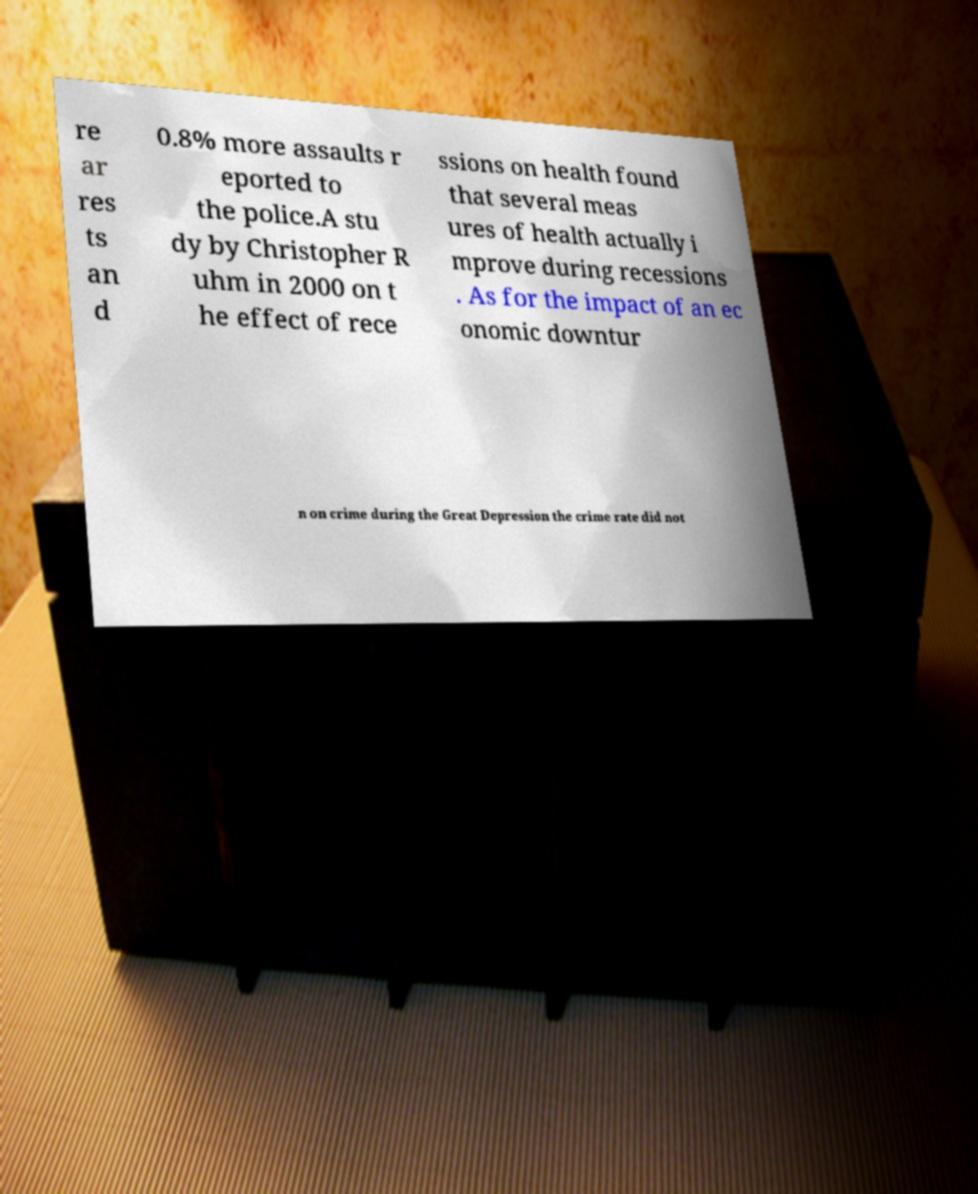Can you read and provide the text displayed in the image?This photo seems to have some interesting text. Can you extract and type it out for me? re ar res ts an d 0.8% more assaults r eported to the police.A stu dy by Christopher R uhm in 2000 on t he effect of rece ssions on health found that several meas ures of health actually i mprove during recessions . As for the impact of an ec onomic downtur n on crime during the Great Depression the crime rate did not 